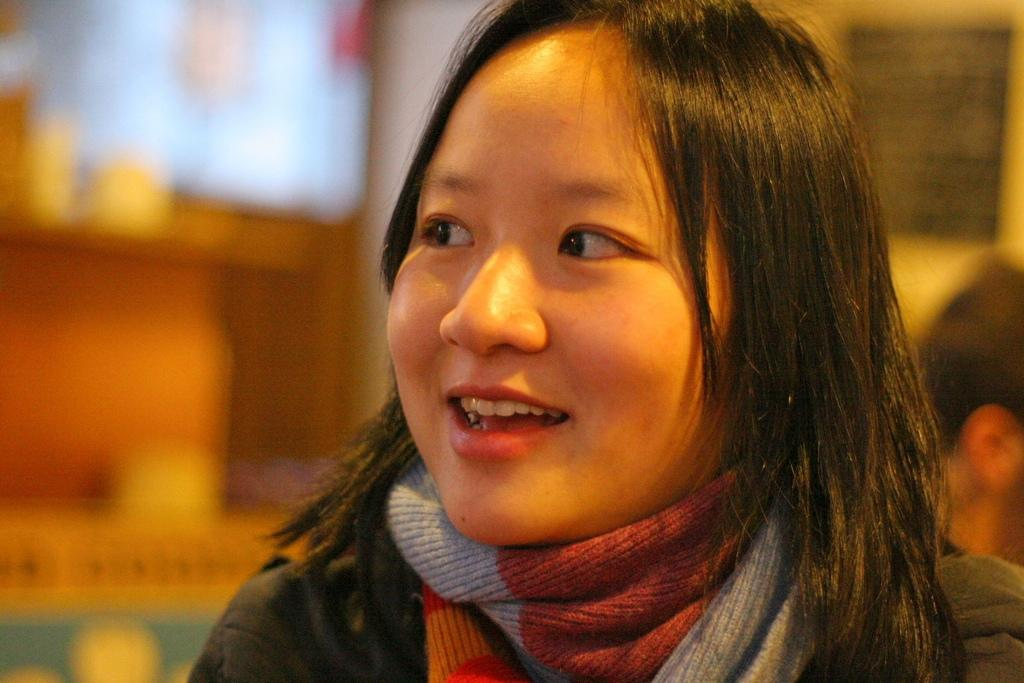Who is the main subject in the image? There is a lady in the image. What is the lady wearing in the image? The lady is wearing a scarf. What is the lady's facial expression in the image? The lady is smiling. Can you describe the background of the image? The background of the image is blurred. What type of cactus can be seen in the background of the image? There is no cactus present in the image; the background is blurred. How does the lady use the comb in the image? There is no comb present in the image. 